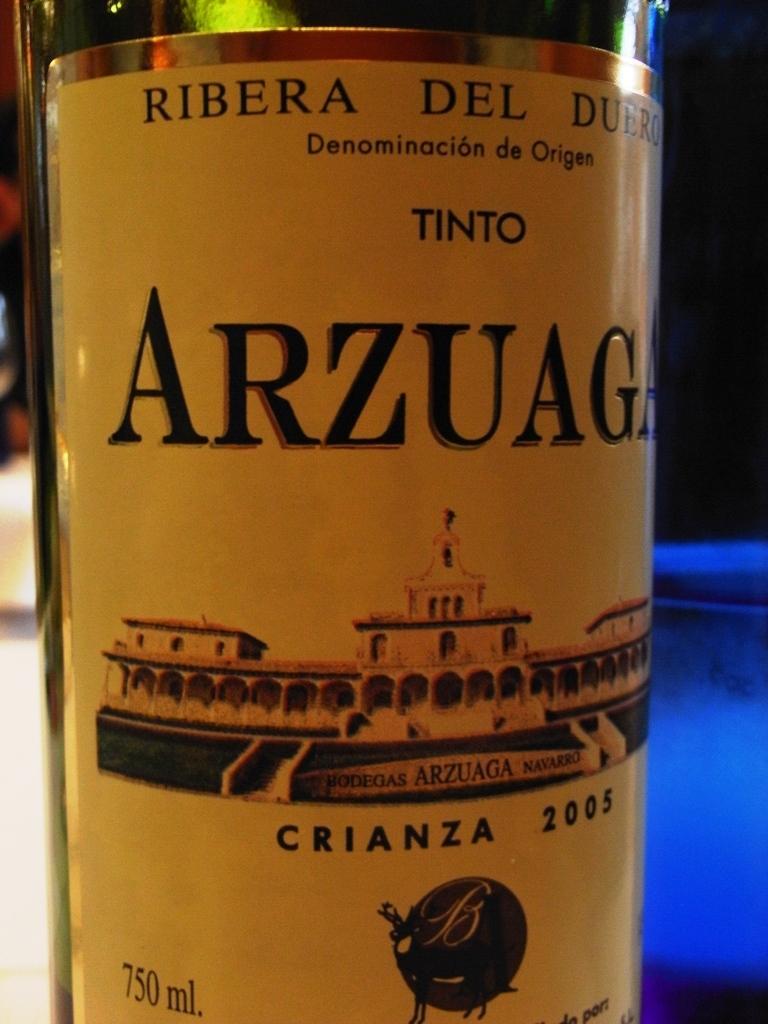Please provide a concise description of this image. Here there is a black and yellow label wine bottle scene in the image. 